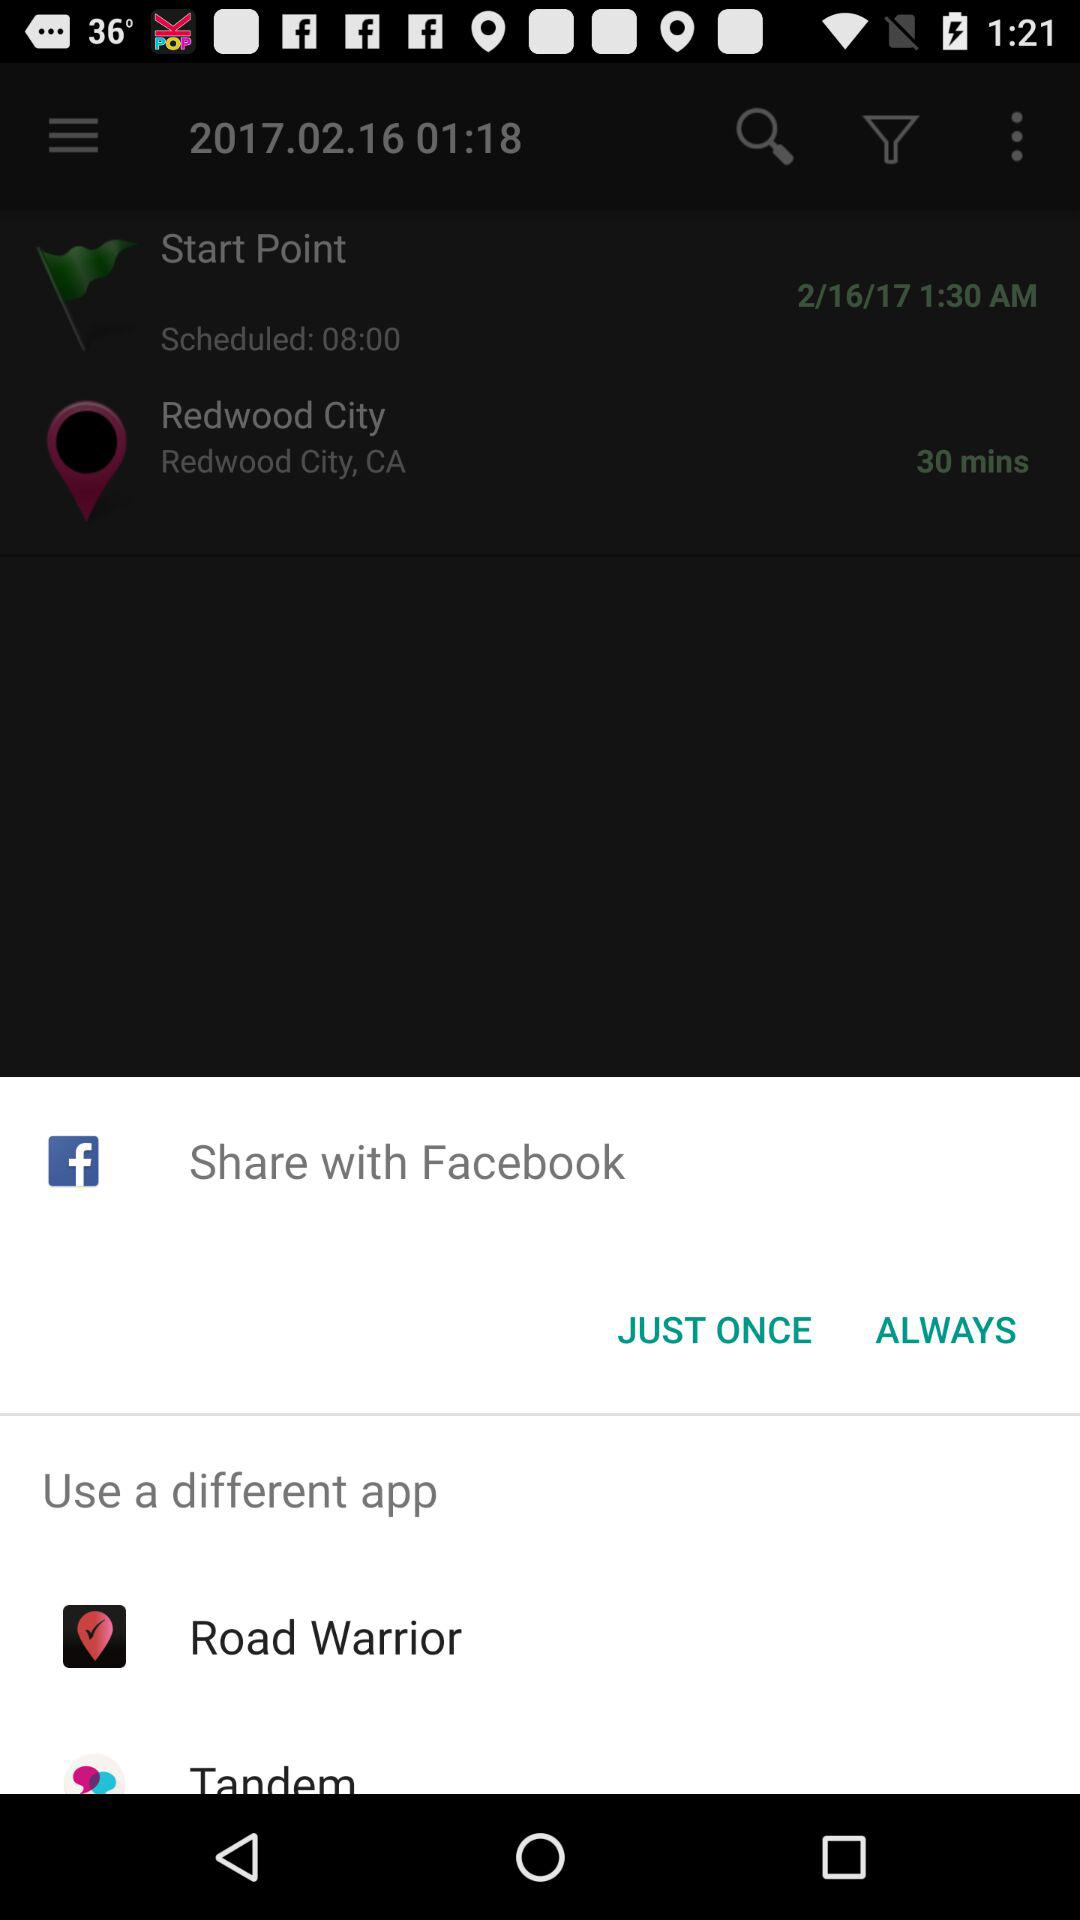How many more minutes are there until the start of the trip?
Answer the question using a single word or phrase. 30 